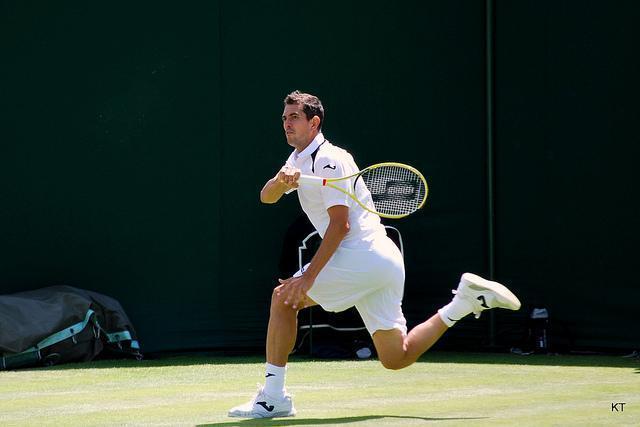How many hand the player use to hold the racket?
Give a very brief answer. 1. 